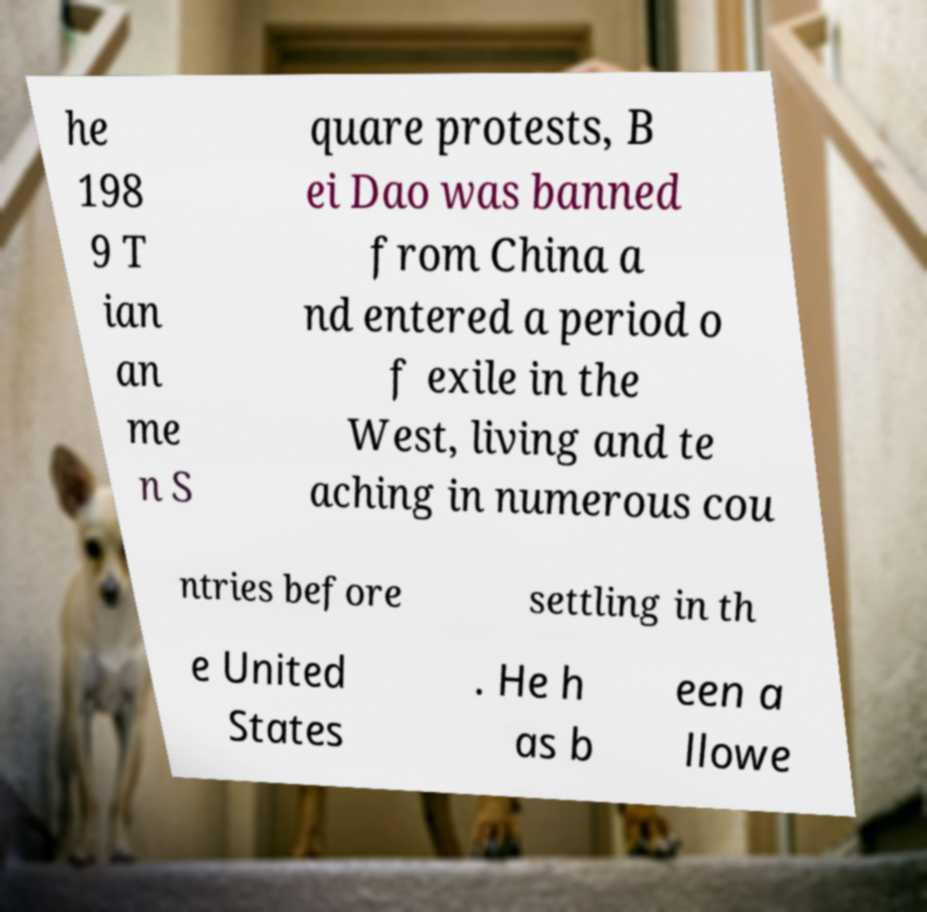Can you accurately transcribe the text from the provided image for me? he 198 9 T ian an me n S quare protests, B ei Dao was banned from China a nd entered a period o f exile in the West, living and te aching in numerous cou ntries before settling in th e United States . He h as b een a llowe 